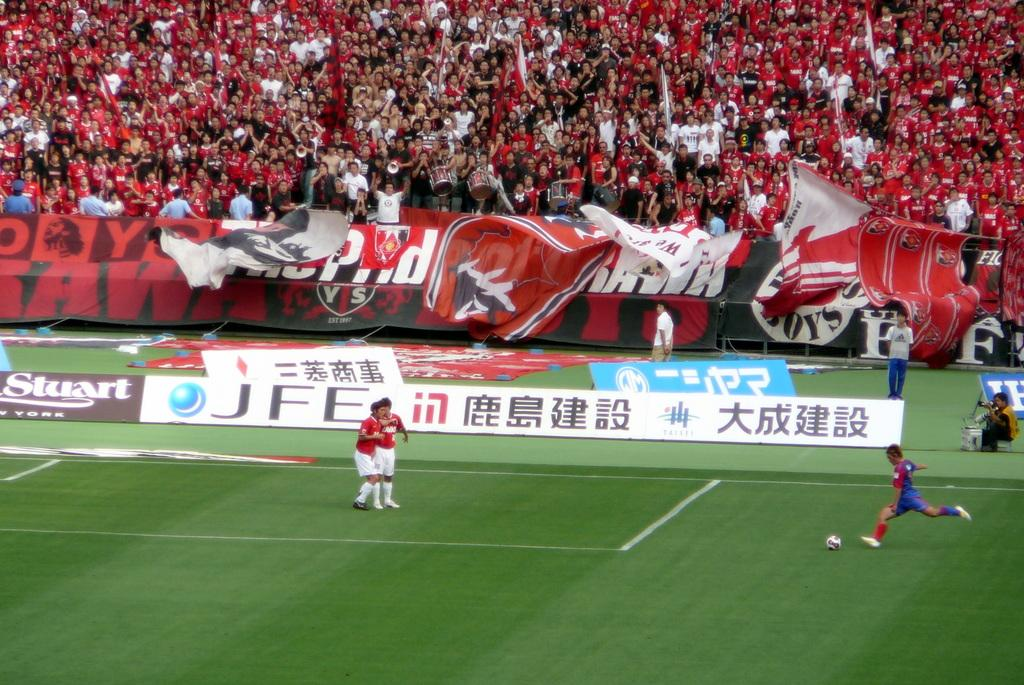<image>
Give a short and clear explanation of the subsequent image. A stadium of soccer fans are dressed in red, as  teams play in front of a JFE board. 